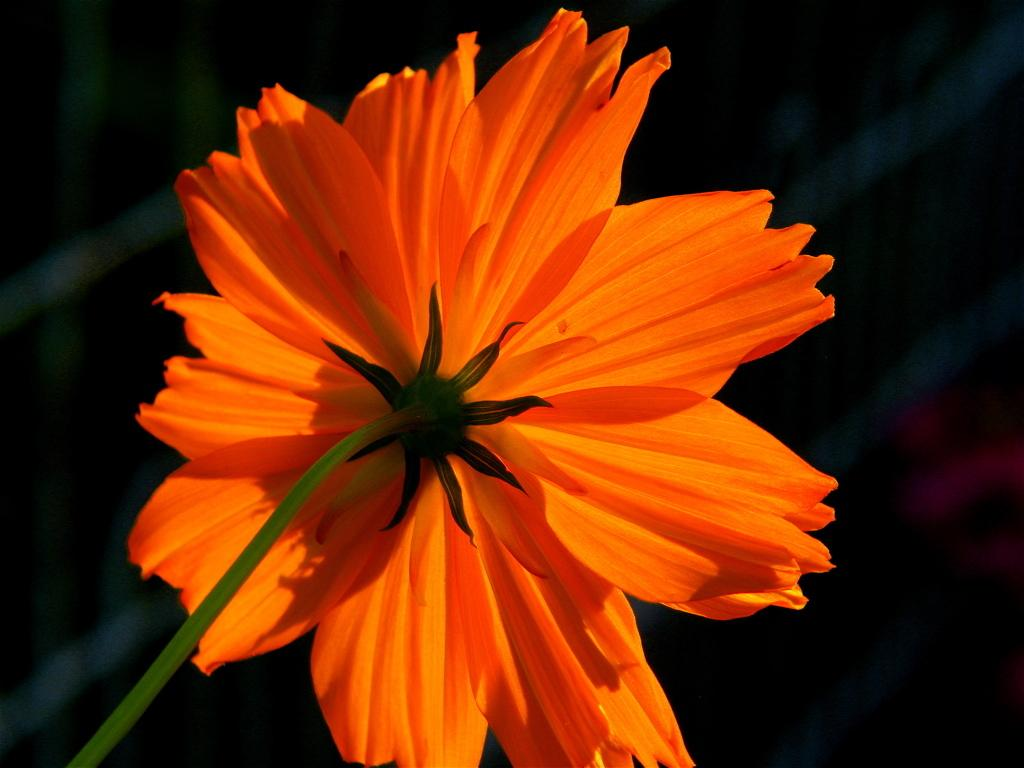What is the main subject of the image? There is a flower in the center of the image. Can you describe the flower in more detail? Unfortunately, the facts provided do not give any additional details about the flower. Is there anything else in the image besides the flower? The facts provided do not mention any other objects or subjects in the image. How many hands are holding the flower in the image? There are no hands visible in the image, as it only features a flower in the center. What type of coast can be seen in the background of the image? There is no coast present in the image, as it only features a flower in the center. 